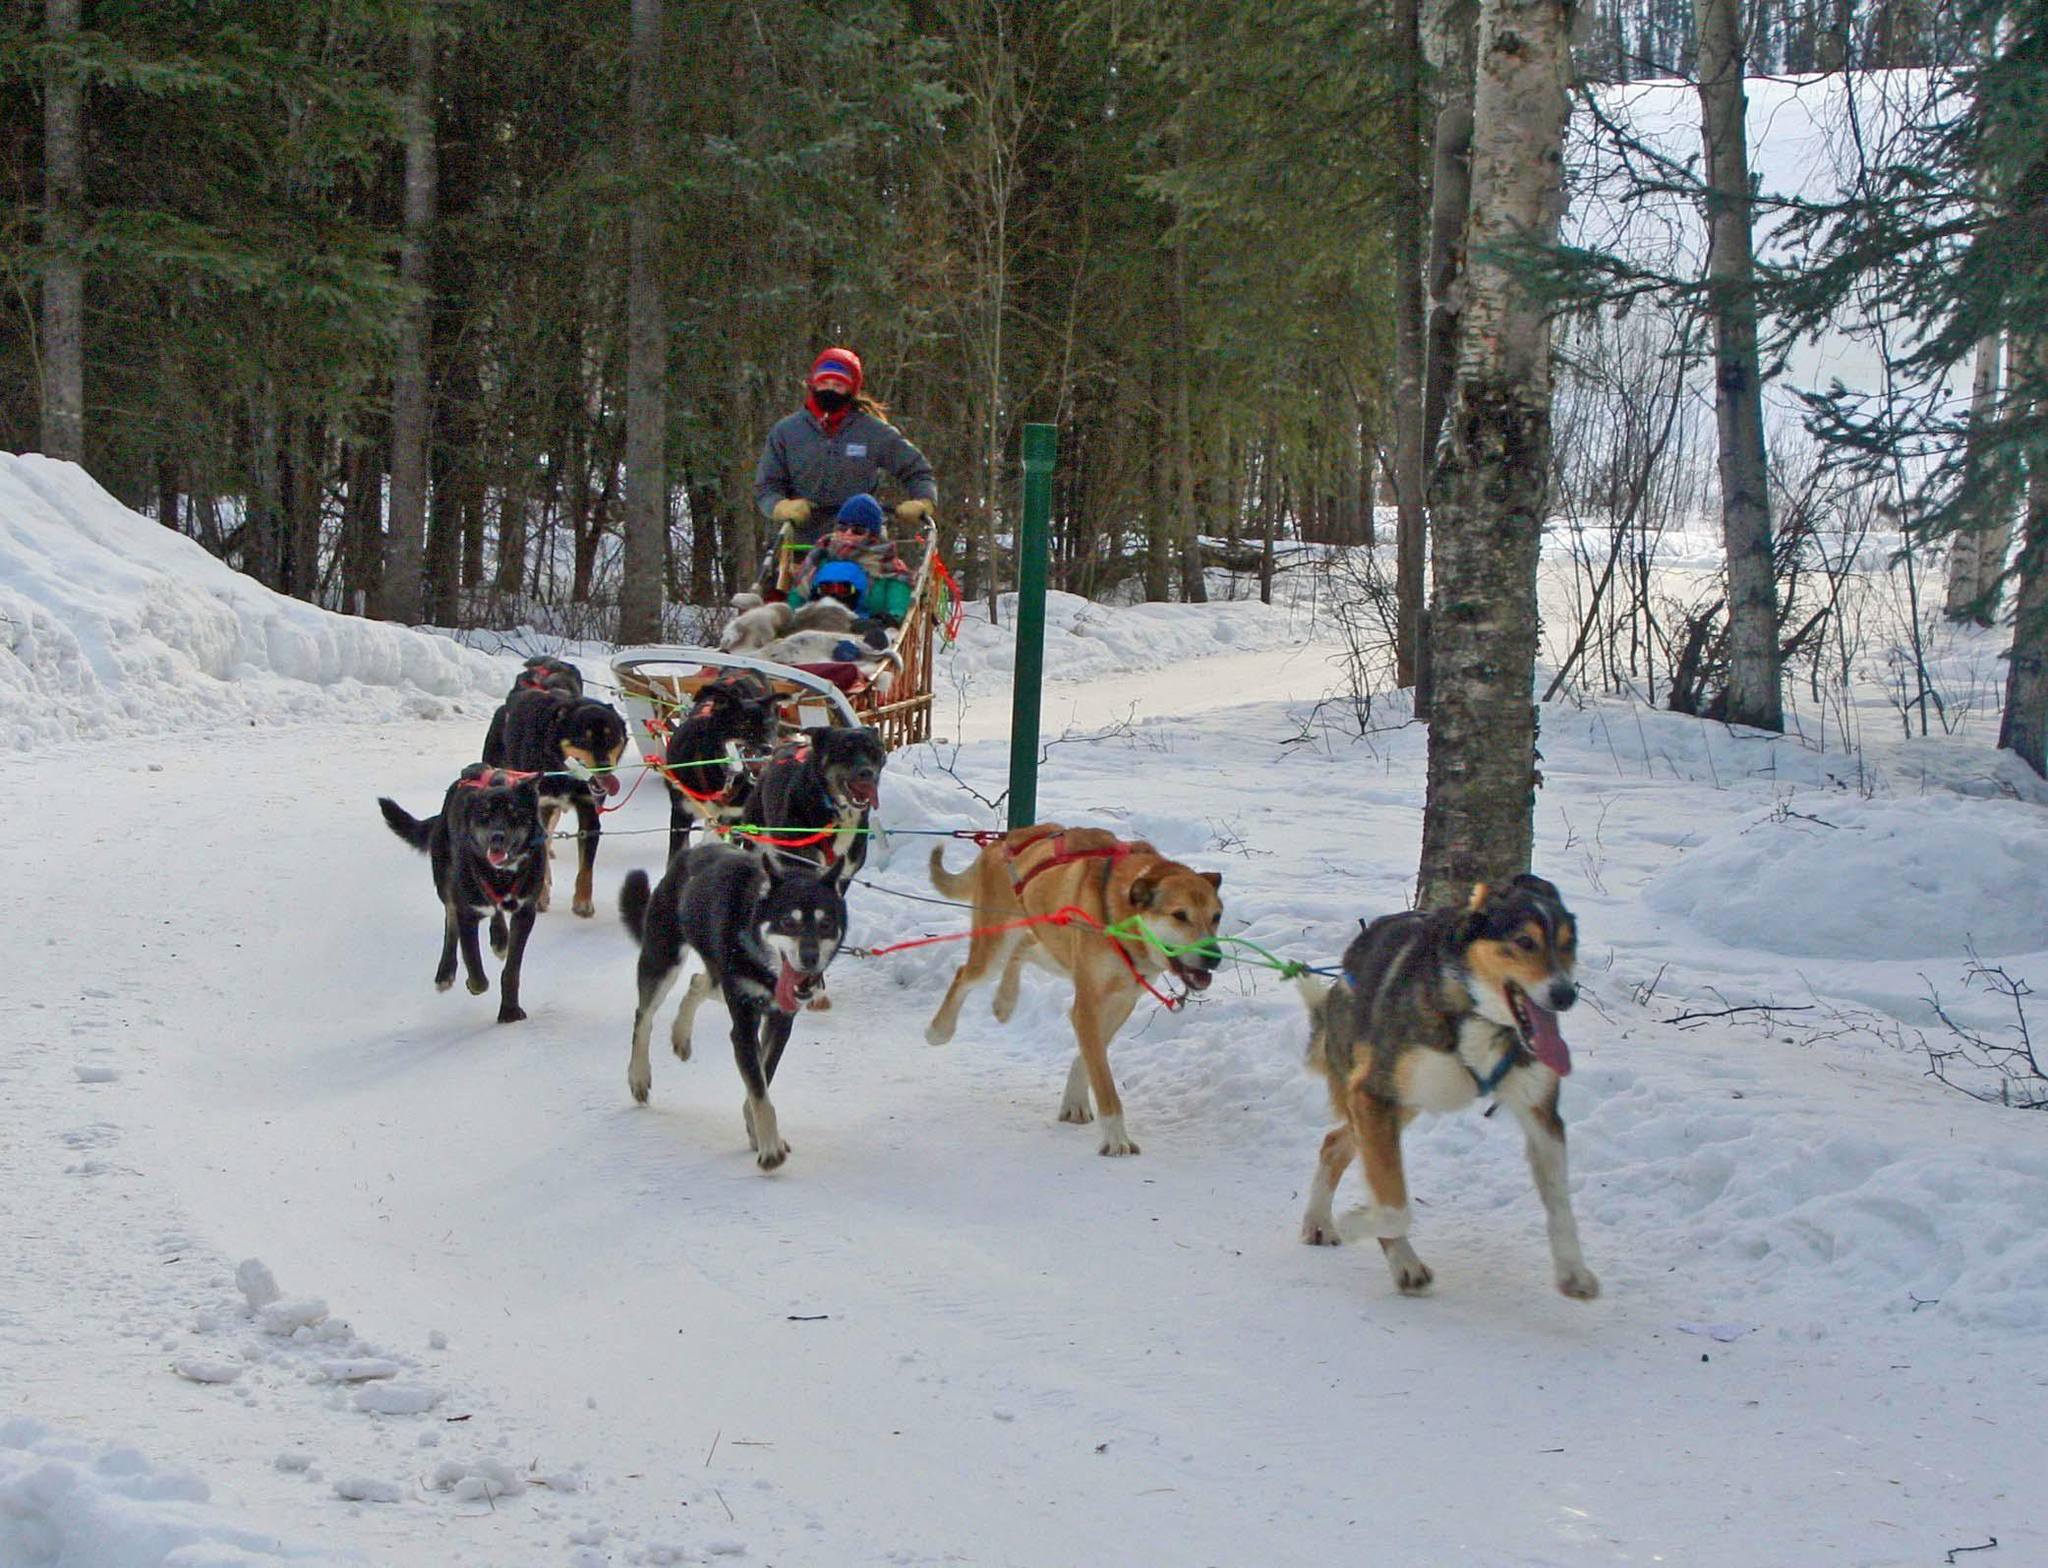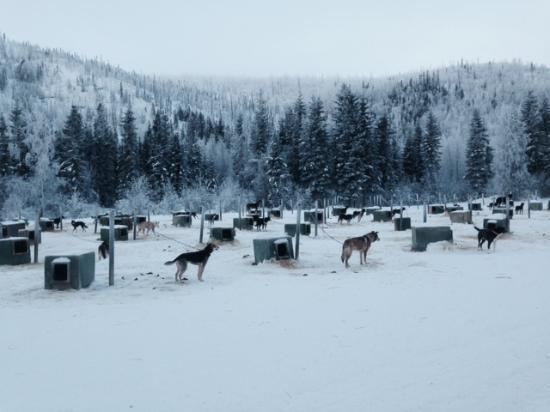The first image is the image on the left, the second image is the image on the right. For the images displayed, is the sentence "One image shows a dog team running forward toward the right, and the other image includes box-shaped doghouses along the horizon in front of evergreens and tall hills." factually correct? Answer yes or no. Yes. The first image is the image on the left, the second image is the image on the right. Evaluate the accuracy of this statement regarding the images: "In one image, sled dogs are standing at their base camp, and in the second image, they are running to pull a sled for a driver.". Is it true? Answer yes or no. Yes. 